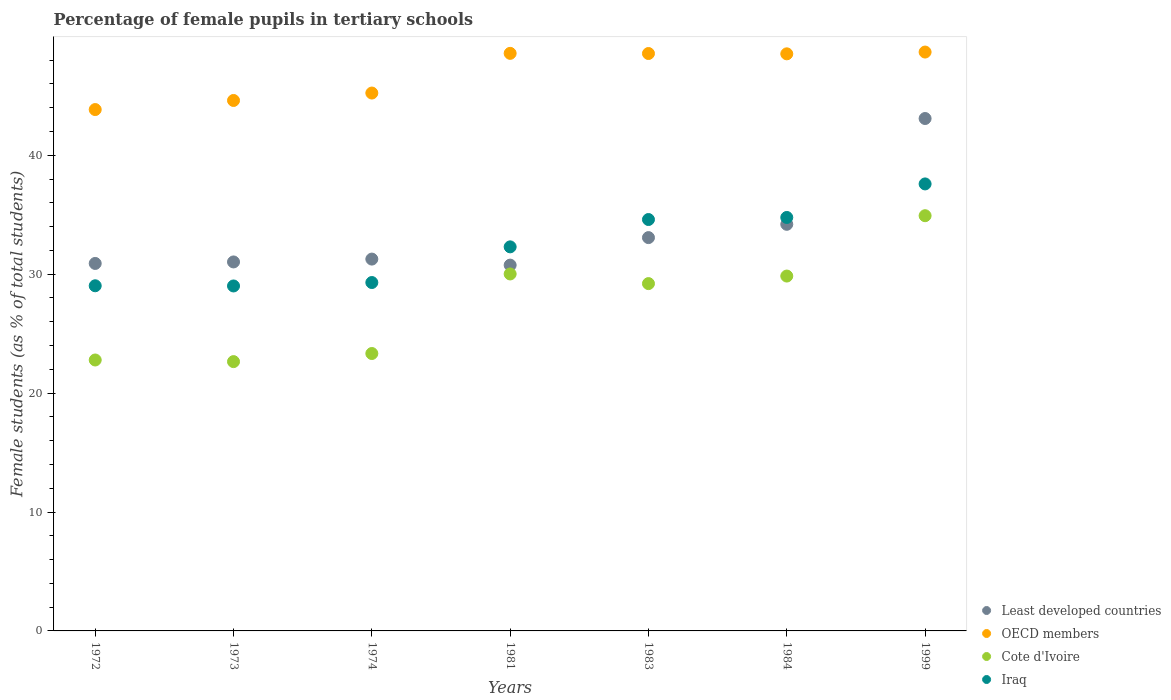How many different coloured dotlines are there?
Your response must be concise. 4. What is the percentage of female pupils in tertiary schools in Cote d'Ivoire in 1999?
Make the answer very short. 34.92. Across all years, what is the maximum percentage of female pupils in tertiary schools in Iraq?
Provide a succinct answer. 37.59. Across all years, what is the minimum percentage of female pupils in tertiary schools in Least developed countries?
Make the answer very short. 30.76. What is the total percentage of female pupils in tertiary schools in Least developed countries in the graph?
Your answer should be compact. 234.33. What is the difference between the percentage of female pupils in tertiary schools in OECD members in 1974 and that in 1999?
Ensure brevity in your answer.  -3.45. What is the difference between the percentage of female pupils in tertiary schools in Iraq in 1972 and the percentage of female pupils in tertiary schools in Cote d'Ivoire in 1999?
Make the answer very short. -5.89. What is the average percentage of female pupils in tertiary schools in Least developed countries per year?
Provide a short and direct response. 33.48. In the year 1972, what is the difference between the percentage of female pupils in tertiary schools in Cote d'Ivoire and percentage of female pupils in tertiary schools in OECD members?
Offer a terse response. -21.06. What is the ratio of the percentage of female pupils in tertiary schools in Iraq in 1972 to that in 1999?
Ensure brevity in your answer.  0.77. Is the percentage of female pupils in tertiary schools in Cote d'Ivoire in 1981 less than that in 1984?
Make the answer very short. No. What is the difference between the highest and the second highest percentage of female pupils in tertiary schools in Least developed countries?
Make the answer very short. 8.9. What is the difference between the highest and the lowest percentage of female pupils in tertiary schools in OECD members?
Offer a terse response. 4.84. How many dotlines are there?
Provide a short and direct response. 4. How many years are there in the graph?
Your response must be concise. 7. What is the difference between two consecutive major ticks on the Y-axis?
Offer a terse response. 10. Does the graph contain any zero values?
Give a very brief answer. No. How many legend labels are there?
Your response must be concise. 4. How are the legend labels stacked?
Your answer should be compact. Vertical. What is the title of the graph?
Offer a terse response. Percentage of female pupils in tertiary schools. Does "Haiti" appear as one of the legend labels in the graph?
Your response must be concise. No. What is the label or title of the X-axis?
Provide a short and direct response. Years. What is the label or title of the Y-axis?
Give a very brief answer. Female students (as % of total students). What is the Female students (as % of total students) of Least developed countries in 1972?
Provide a succinct answer. 30.9. What is the Female students (as % of total students) in OECD members in 1972?
Offer a terse response. 43.84. What is the Female students (as % of total students) in Cote d'Ivoire in 1972?
Ensure brevity in your answer.  22.78. What is the Female students (as % of total students) in Iraq in 1972?
Keep it short and to the point. 29.03. What is the Female students (as % of total students) of Least developed countries in 1973?
Your answer should be compact. 31.03. What is the Female students (as % of total students) of OECD members in 1973?
Provide a succinct answer. 44.61. What is the Female students (as % of total students) of Cote d'Ivoire in 1973?
Make the answer very short. 22.65. What is the Female students (as % of total students) in Iraq in 1973?
Offer a terse response. 29.01. What is the Female students (as % of total students) of Least developed countries in 1974?
Make the answer very short. 31.27. What is the Female students (as % of total students) in OECD members in 1974?
Provide a short and direct response. 45.23. What is the Female students (as % of total students) in Cote d'Ivoire in 1974?
Offer a terse response. 23.33. What is the Female students (as % of total students) in Iraq in 1974?
Your answer should be very brief. 29.3. What is the Female students (as % of total students) of Least developed countries in 1981?
Provide a succinct answer. 30.76. What is the Female students (as % of total students) of OECD members in 1981?
Give a very brief answer. 48.57. What is the Female students (as % of total students) of Cote d'Ivoire in 1981?
Provide a succinct answer. 30.02. What is the Female students (as % of total students) of Iraq in 1981?
Offer a terse response. 32.3. What is the Female students (as % of total students) in Least developed countries in 1983?
Your answer should be very brief. 33.08. What is the Female students (as % of total students) of OECD members in 1983?
Keep it short and to the point. 48.56. What is the Female students (as % of total students) of Cote d'Ivoire in 1983?
Keep it short and to the point. 29.21. What is the Female students (as % of total students) in Iraq in 1983?
Your response must be concise. 34.6. What is the Female students (as % of total students) of Least developed countries in 1984?
Offer a very short reply. 34.19. What is the Female students (as % of total students) in OECD members in 1984?
Offer a terse response. 48.53. What is the Female students (as % of total students) of Cote d'Ivoire in 1984?
Ensure brevity in your answer.  29.84. What is the Female students (as % of total students) in Iraq in 1984?
Your response must be concise. 34.77. What is the Female students (as % of total students) in Least developed countries in 1999?
Keep it short and to the point. 43.09. What is the Female students (as % of total students) in OECD members in 1999?
Your answer should be compact. 48.68. What is the Female students (as % of total students) of Cote d'Ivoire in 1999?
Your answer should be compact. 34.92. What is the Female students (as % of total students) in Iraq in 1999?
Provide a succinct answer. 37.59. Across all years, what is the maximum Female students (as % of total students) of Least developed countries?
Your answer should be compact. 43.09. Across all years, what is the maximum Female students (as % of total students) in OECD members?
Your answer should be very brief. 48.68. Across all years, what is the maximum Female students (as % of total students) of Cote d'Ivoire?
Offer a terse response. 34.92. Across all years, what is the maximum Female students (as % of total students) of Iraq?
Give a very brief answer. 37.59. Across all years, what is the minimum Female students (as % of total students) in Least developed countries?
Make the answer very short. 30.76. Across all years, what is the minimum Female students (as % of total students) of OECD members?
Make the answer very short. 43.84. Across all years, what is the minimum Female students (as % of total students) of Cote d'Ivoire?
Keep it short and to the point. 22.65. Across all years, what is the minimum Female students (as % of total students) in Iraq?
Provide a succinct answer. 29.01. What is the total Female students (as % of total students) of Least developed countries in the graph?
Offer a very short reply. 234.33. What is the total Female students (as % of total students) in OECD members in the graph?
Your answer should be very brief. 328.02. What is the total Female students (as % of total students) of Cote d'Ivoire in the graph?
Offer a very short reply. 192.75. What is the total Female students (as % of total students) of Iraq in the graph?
Your answer should be very brief. 226.59. What is the difference between the Female students (as % of total students) in Least developed countries in 1972 and that in 1973?
Your answer should be very brief. -0.13. What is the difference between the Female students (as % of total students) of OECD members in 1972 and that in 1973?
Provide a short and direct response. -0.76. What is the difference between the Female students (as % of total students) of Cote d'Ivoire in 1972 and that in 1973?
Keep it short and to the point. 0.14. What is the difference between the Female students (as % of total students) in Iraq in 1972 and that in 1973?
Your answer should be very brief. 0.02. What is the difference between the Female students (as % of total students) of Least developed countries in 1972 and that in 1974?
Make the answer very short. -0.37. What is the difference between the Female students (as % of total students) of OECD members in 1972 and that in 1974?
Your response must be concise. -1.39. What is the difference between the Female students (as % of total students) in Cote d'Ivoire in 1972 and that in 1974?
Give a very brief answer. -0.54. What is the difference between the Female students (as % of total students) in Iraq in 1972 and that in 1974?
Offer a very short reply. -0.27. What is the difference between the Female students (as % of total students) in Least developed countries in 1972 and that in 1981?
Provide a succinct answer. 0.14. What is the difference between the Female students (as % of total students) of OECD members in 1972 and that in 1981?
Keep it short and to the point. -4.73. What is the difference between the Female students (as % of total students) in Cote d'Ivoire in 1972 and that in 1981?
Provide a short and direct response. -7.24. What is the difference between the Female students (as % of total students) of Iraq in 1972 and that in 1981?
Provide a short and direct response. -3.27. What is the difference between the Female students (as % of total students) in Least developed countries in 1972 and that in 1983?
Your response must be concise. -2.17. What is the difference between the Female students (as % of total students) of OECD members in 1972 and that in 1983?
Offer a very short reply. -4.71. What is the difference between the Female students (as % of total students) of Cote d'Ivoire in 1972 and that in 1983?
Your answer should be compact. -6.42. What is the difference between the Female students (as % of total students) of Iraq in 1972 and that in 1983?
Offer a terse response. -5.57. What is the difference between the Female students (as % of total students) of Least developed countries in 1972 and that in 1984?
Provide a succinct answer. -3.29. What is the difference between the Female students (as % of total students) of OECD members in 1972 and that in 1984?
Give a very brief answer. -4.69. What is the difference between the Female students (as % of total students) in Cote d'Ivoire in 1972 and that in 1984?
Provide a succinct answer. -7.06. What is the difference between the Female students (as % of total students) of Iraq in 1972 and that in 1984?
Provide a succinct answer. -5.74. What is the difference between the Female students (as % of total students) in Least developed countries in 1972 and that in 1999?
Your answer should be very brief. -12.19. What is the difference between the Female students (as % of total students) in OECD members in 1972 and that in 1999?
Make the answer very short. -4.84. What is the difference between the Female students (as % of total students) in Cote d'Ivoire in 1972 and that in 1999?
Offer a very short reply. -12.13. What is the difference between the Female students (as % of total students) in Iraq in 1972 and that in 1999?
Your response must be concise. -8.56. What is the difference between the Female students (as % of total students) of Least developed countries in 1973 and that in 1974?
Your answer should be compact. -0.24. What is the difference between the Female students (as % of total students) of OECD members in 1973 and that in 1974?
Make the answer very short. -0.62. What is the difference between the Female students (as % of total students) in Cote d'Ivoire in 1973 and that in 1974?
Make the answer very short. -0.68. What is the difference between the Female students (as % of total students) in Iraq in 1973 and that in 1974?
Make the answer very short. -0.29. What is the difference between the Female students (as % of total students) of Least developed countries in 1973 and that in 1981?
Ensure brevity in your answer.  0.27. What is the difference between the Female students (as % of total students) of OECD members in 1973 and that in 1981?
Ensure brevity in your answer.  -3.96. What is the difference between the Female students (as % of total students) of Cote d'Ivoire in 1973 and that in 1981?
Your answer should be compact. -7.37. What is the difference between the Female students (as % of total students) in Iraq in 1973 and that in 1981?
Provide a short and direct response. -3.29. What is the difference between the Female students (as % of total students) in Least developed countries in 1973 and that in 1983?
Provide a short and direct response. -2.05. What is the difference between the Female students (as % of total students) of OECD members in 1973 and that in 1983?
Ensure brevity in your answer.  -3.95. What is the difference between the Female students (as % of total students) of Cote d'Ivoire in 1973 and that in 1983?
Make the answer very short. -6.56. What is the difference between the Female students (as % of total students) in Iraq in 1973 and that in 1983?
Provide a succinct answer. -5.59. What is the difference between the Female students (as % of total students) in Least developed countries in 1973 and that in 1984?
Offer a very short reply. -3.16. What is the difference between the Female students (as % of total students) in OECD members in 1973 and that in 1984?
Make the answer very short. -3.92. What is the difference between the Female students (as % of total students) in Cote d'Ivoire in 1973 and that in 1984?
Your answer should be compact. -7.2. What is the difference between the Female students (as % of total students) in Iraq in 1973 and that in 1984?
Provide a short and direct response. -5.76. What is the difference between the Female students (as % of total students) in Least developed countries in 1973 and that in 1999?
Make the answer very short. -12.06. What is the difference between the Female students (as % of total students) of OECD members in 1973 and that in 1999?
Keep it short and to the point. -4.07. What is the difference between the Female students (as % of total students) of Cote d'Ivoire in 1973 and that in 1999?
Provide a succinct answer. -12.27. What is the difference between the Female students (as % of total students) of Iraq in 1973 and that in 1999?
Offer a terse response. -8.58. What is the difference between the Female students (as % of total students) of Least developed countries in 1974 and that in 1981?
Your answer should be very brief. 0.51. What is the difference between the Female students (as % of total students) in OECD members in 1974 and that in 1981?
Offer a terse response. -3.34. What is the difference between the Female students (as % of total students) of Cote d'Ivoire in 1974 and that in 1981?
Ensure brevity in your answer.  -6.69. What is the difference between the Female students (as % of total students) of Iraq in 1974 and that in 1981?
Offer a terse response. -3. What is the difference between the Female students (as % of total students) in Least developed countries in 1974 and that in 1983?
Provide a succinct answer. -1.81. What is the difference between the Female students (as % of total students) in OECD members in 1974 and that in 1983?
Provide a short and direct response. -3.32. What is the difference between the Female students (as % of total students) of Cote d'Ivoire in 1974 and that in 1983?
Offer a very short reply. -5.88. What is the difference between the Female students (as % of total students) of Iraq in 1974 and that in 1983?
Provide a succinct answer. -5.3. What is the difference between the Female students (as % of total students) of Least developed countries in 1974 and that in 1984?
Your answer should be compact. -2.93. What is the difference between the Female students (as % of total students) in OECD members in 1974 and that in 1984?
Provide a short and direct response. -3.3. What is the difference between the Female students (as % of total students) of Cote d'Ivoire in 1974 and that in 1984?
Offer a terse response. -6.51. What is the difference between the Female students (as % of total students) in Iraq in 1974 and that in 1984?
Offer a terse response. -5.47. What is the difference between the Female students (as % of total students) in Least developed countries in 1974 and that in 1999?
Keep it short and to the point. -11.82. What is the difference between the Female students (as % of total students) of OECD members in 1974 and that in 1999?
Make the answer very short. -3.45. What is the difference between the Female students (as % of total students) of Cote d'Ivoire in 1974 and that in 1999?
Provide a succinct answer. -11.59. What is the difference between the Female students (as % of total students) in Iraq in 1974 and that in 1999?
Provide a succinct answer. -8.29. What is the difference between the Female students (as % of total students) in Least developed countries in 1981 and that in 1983?
Provide a short and direct response. -2.31. What is the difference between the Female students (as % of total students) in OECD members in 1981 and that in 1983?
Your response must be concise. 0.01. What is the difference between the Female students (as % of total students) in Cote d'Ivoire in 1981 and that in 1983?
Your answer should be compact. 0.81. What is the difference between the Female students (as % of total students) of Iraq in 1981 and that in 1983?
Offer a very short reply. -2.3. What is the difference between the Female students (as % of total students) in Least developed countries in 1981 and that in 1984?
Keep it short and to the point. -3.43. What is the difference between the Female students (as % of total students) of OECD members in 1981 and that in 1984?
Your answer should be compact. 0.04. What is the difference between the Female students (as % of total students) in Cote d'Ivoire in 1981 and that in 1984?
Your response must be concise. 0.18. What is the difference between the Female students (as % of total students) in Iraq in 1981 and that in 1984?
Offer a terse response. -2.47. What is the difference between the Female students (as % of total students) in Least developed countries in 1981 and that in 1999?
Your answer should be compact. -12.33. What is the difference between the Female students (as % of total students) in OECD members in 1981 and that in 1999?
Provide a succinct answer. -0.11. What is the difference between the Female students (as % of total students) in Cote d'Ivoire in 1981 and that in 1999?
Offer a terse response. -4.9. What is the difference between the Female students (as % of total students) in Iraq in 1981 and that in 1999?
Your answer should be compact. -5.29. What is the difference between the Female students (as % of total students) of Least developed countries in 1983 and that in 1984?
Your response must be concise. -1.12. What is the difference between the Female students (as % of total students) of OECD members in 1983 and that in 1984?
Your answer should be compact. 0.03. What is the difference between the Female students (as % of total students) of Cote d'Ivoire in 1983 and that in 1984?
Make the answer very short. -0.63. What is the difference between the Female students (as % of total students) of Iraq in 1983 and that in 1984?
Provide a succinct answer. -0.17. What is the difference between the Female students (as % of total students) in Least developed countries in 1983 and that in 1999?
Offer a terse response. -10.02. What is the difference between the Female students (as % of total students) of OECD members in 1983 and that in 1999?
Provide a short and direct response. -0.12. What is the difference between the Female students (as % of total students) of Cote d'Ivoire in 1983 and that in 1999?
Provide a short and direct response. -5.71. What is the difference between the Female students (as % of total students) in Iraq in 1983 and that in 1999?
Provide a succinct answer. -2.99. What is the difference between the Female students (as % of total students) in Least developed countries in 1984 and that in 1999?
Offer a terse response. -8.9. What is the difference between the Female students (as % of total students) of OECD members in 1984 and that in 1999?
Offer a very short reply. -0.15. What is the difference between the Female students (as % of total students) in Cote d'Ivoire in 1984 and that in 1999?
Your response must be concise. -5.08. What is the difference between the Female students (as % of total students) in Iraq in 1984 and that in 1999?
Your answer should be compact. -2.82. What is the difference between the Female students (as % of total students) of Least developed countries in 1972 and the Female students (as % of total students) of OECD members in 1973?
Offer a very short reply. -13.71. What is the difference between the Female students (as % of total students) in Least developed countries in 1972 and the Female students (as % of total students) in Cote d'Ivoire in 1973?
Your answer should be compact. 8.26. What is the difference between the Female students (as % of total students) of Least developed countries in 1972 and the Female students (as % of total students) of Iraq in 1973?
Offer a very short reply. 1.89. What is the difference between the Female students (as % of total students) of OECD members in 1972 and the Female students (as % of total students) of Cote d'Ivoire in 1973?
Keep it short and to the point. 21.2. What is the difference between the Female students (as % of total students) in OECD members in 1972 and the Female students (as % of total students) in Iraq in 1973?
Make the answer very short. 14.83. What is the difference between the Female students (as % of total students) of Cote d'Ivoire in 1972 and the Female students (as % of total students) of Iraq in 1973?
Make the answer very short. -6.23. What is the difference between the Female students (as % of total students) of Least developed countries in 1972 and the Female students (as % of total students) of OECD members in 1974?
Offer a very short reply. -14.33. What is the difference between the Female students (as % of total students) of Least developed countries in 1972 and the Female students (as % of total students) of Cote d'Ivoire in 1974?
Give a very brief answer. 7.57. What is the difference between the Female students (as % of total students) of Least developed countries in 1972 and the Female students (as % of total students) of Iraq in 1974?
Provide a short and direct response. 1.6. What is the difference between the Female students (as % of total students) in OECD members in 1972 and the Female students (as % of total students) in Cote d'Ivoire in 1974?
Your answer should be compact. 20.52. What is the difference between the Female students (as % of total students) in OECD members in 1972 and the Female students (as % of total students) in Iraq in 1974?
Offer a terse response. 14.55. What is the difference between the Female students (as % of total students) of Cote d'Ivoire in 1972 and the Female students (as % of total students) of Iraq in 1974?
Your answer should be very brief. -6.51. What is the difference between the Female students (as % of total students) in Least developed countries in 1972 and the Female students (as % of total students) in OECD members in 1981?
Your response must be concise. -17.67. What is the difference between the Female students (as % of total students) in Least developed countries in 1972 and the Female students (as % of total students) in Cote d'Ivoire in 1981?
Give a very brief answer. 0.88. What is the difference between the Female students (as % of total students) in Least developed countries in 1972 and the Female students (as % of total students) in Iraq in 1981?
Offer a very short reply. -1.4. What is the difference between the Female students (as % of total students) of OECD members in 1972 and the Female students (as % of total students) of Cote d'Ivoire in 1981?
Ensure brevity in your answer.  13.83. What is the difference between the Female students (as % of total students) of OECD members in 1972 and the Female students (as % of total students) of Iraq in 1981?
Ensure brevity in your answer.  11.55. What is the difference between the Female students (as % of total students) in Cote d'Ivoire in 1972 and the Female students (as % of total students) in Iraq in 1981?
Your response must be concise. -9.51. What is the difference between the Female students (as % of total students) of Least developed countries in 1972 and the Female students (as % of total students) of OECD members in 1983?
Provide a succinct answer. -17.65. What is the difference between the Female students (as % of total students) in Least developed countries in 1972 and the Female students (as % of total students) in Cote d'Ivoire in 1983?
Offer a very short reply. 1.69. What is the difference between the Female students (as % of total students) of Least developed countries in 1972 and the Female students (as % of total students) of Iraq in 1983?
Your answer should be very brief. -3.69. What is the difference between the Female students (as % of total students) in OECD members in 1972 and the Female students (as % of total students) in Cote d'Ivoire in 1983?
Your answer should be compact. 14.64. What is the difference between the Female students (as % of total students) in OECD members in 1972 and the Female students (as % of total students) in Iraq in 1983?
Your response must be concise. 9.25. What is the difference between the Female students (as % of total students) of Cote d'Ivoire in 1972 and the Female students (as % of total students) of Iraq in 1983?
Give a very brief answer. -11.81. What is the difference between the Female students (as % of total students) in Least developed countries in 1972 and the Female students (as % of total students) in OECD members in 1984?
Give a very brief answer. -17.63. What is the difference between the Female students (as % of total students) in Least developed countries in 1972 and the Female students (as % of total students) in Cote d'Ivoire in 1984?
Keep it short and to the point. 1.06. What is the difference between the Female students (as % of total students) in Least developed countries in 1972 and the Female students (as % of total students) in Iraq in 1984?
Offer a terse response. -3.87. What is the difference between the Female students (as % of total students) in OECD members in 1972 and the Female students (as % of total students) in Cote d'Ivoire in 1984?
Make the answer very short. 14. What is the difference between the Female students (as % of total students) of OECD members in 1972 and the Female students (as % of total students) of Iraq in 1984?
Offer a very short reply. 9.07. What is the difference between the Female students (as % of total students) in Cote d'Ivoire in 1972 and the Female students (as % of total students) in Iraq in 1984?
Provide a succinct answer. -11.99. What is the difference between the Female students (as % of total students) of Least developed countries in 1972 and the Female students (as % of total students) of OECD members in 1999?
Ensure brevity in your answer.  -17.78. What is the difference between the Female students (as % of total students) in Least developed countries in 1972 and the Female students (as % of total students) in Cote d'Ivoire in 1999?
Offer a very short reply. -4.02. What is the difference between the Female students (as % of total students) of Least developed countries in 1972 and the Female students (as % of total students) of Iraq in 1999?
Offer a terse response. -6.69. What is the difference between the Female students (as % of total students) in OECD members in 1972 and the Female students (as % of total students) in Cote d'Ivoire in 1999?
Provide a succinct answer. 8.93. What is the difference between the Female students (as % of total students) in OECD members in 1972 and the Female students (as % of total students) in Iraq in 1999?
Offer a very short reply. 6.25. What is the difference between the Female students (as % of total students) in Cote d'Ivoire in 1972 and the Female students (as % of total students) in Iraq in 1999?
Keep it short and to the point. -14.81. What is the difference between the Female students (as % of total students) of Least developed countries in 1973 and the Female students (as % of total students) of OECD members in 1974?
Provide a short and direct response. -14.2. What is the difference between the Female students (as % of total students) in Least developed countries in 1973 and the Female students (as % of total students) in Cote d'Ivoire in 1974?
Your answer should be compact. 7.7. What is the difference between the Female students (as % of total students) of Least developed countries in 1973 and the Female students (as % of total students) of Iraq in 1974?
Your response must be concise. 1.73. What is the difference between the Female students (as % of total students) of OECD members in 1973 and the Female students (as % of total students) of Cote d'Ivoire in 1974?
Your response must be concise. 21.28. What is the difference between the Female students (as % of total students) in OECD members in 1973 and the Female students (as % of total students) in Iraq in 1974?
Your response must be concise. 15.31. What is the difference between the Female students (as % of total students) of Cote d'Ivoire in 1973 and the Female students (as % of total students) of Iraq in 1974?
Provide a short and direct response. -6.65. What is the difference between the Female students (as % of total students) of Least developed countries in 1973 and the Female students (as % of total students) of OECD members in 1981?
Ensure brevity in your answer.  -17.54. What is the difference between the Female students (as % of total students) of Least developed countries in 1973 and the Female students (as % of total students) of Cote d'Ivoire in 1981?
Offer a terse response. 1.01. What is the difference between the Female students (as % of total students) of Least developed countries in 1973 and the Female students (as % of total students) of Iraq in 1981?
Your answer should be compact. -1.27. What is the difference between the Female students (as % of total students) of OECD members in 1973 and the Female students (as % of total students) of Cote d'Ivoire in 1981?
Ensure brevity in your answer.  14.59. What is the difference between the Female students (as % of total students) in OECD members in 1973 and the Female students (as % of total students) in Iraq in 1981?
Provide a short and direct response. 12.31. What is the difference between the Female students (as % of total students) in Cote d'Ivoire in 1973 and the Female students (as % of total students) in Iraq in 1981?
Make the answer very short. -9.65. What is the difference between the Female students (as % of total students) of Least developed countries in 1973 and the Female students (as % of total students) of OECD members in 1983?
Provide a succinct answer. -17.53. What is the difference between the Female students (as % of total students) of Least developed countries in 1973 and the Female students (as % of total students) of Cote d'Ivoire in 1983?
Keep it short and to the point. 1.82. What is the difference between the Female students (as % of total students) in Least developed countries in 1973 and the Female students (as % of total students) in Iraq in 1983?
Give a very brief answer. -3.57. What is the difference between the Female students (as % of total students) in OECD members in 1973 and the Female students (as % of total students) in Cote d'Ivoire in 1983?
Provide a short and direct response. 15.4. What is the difference between the Female students (as % of total students) in OECD members in 1973 and the Female students (as % of total students) in Iraq in 1983?
Your answer should be very brief. 10.01. What is the difference between the Female students (as % of total students) in Cote d'Ivoire in 1973 and the Female students (as % of total students) in Iraq in 1983?
Make the answer very short. -11.95. What is the difference between the Female students (as % of total students) in Least developed countries in 1973 and the Female students (as % of total students) in OECD members in 1984?
Provide a succinct answer. -17.5. What is the difference between the Female students (as % of total students) of Least developed countries in 1973 and the Female students (as % of total students) of Cote d'Ivoire in 1984?
Provide a succinct answer. 1.19. What is the difference between the Female students (as % of total students) of Least developed countries in 1973 and the Female students (as % of total students) of Iraq in 1984?
Provide a short and direct response. -3.74. What is the difference between the Female students (as % of total students) in OECD members in 1973 and the Female students (as % of total students) in Cote d'Ivoire in 1984?
Your answer should be compact. 14.77. What is the difference between the Female students (as % of total students) of OECD members in 1973 and the Female students (as % of total students) of Iraq in 1984?
Keep it short and to the point. 9.84. What is the difference between the Female students (as % of total students) of Cote d'Ivoire in 1973 and the Female students (as % of total students) of Iraq in 1984?
Give a very brief answer. -12.12. What is the difference between the Female students (as % of total students) of Least developed countries in 1973 and the Female students (as % of total students) of OECD members in 1999?
Your response must be concise. -17.65. What is the difference between the Female students (as % of total students) of Least developed countries in 1973 and the Female students (as % of total students) of Cote d'Ivoire in 1999?
Ensure brevity in your answer.  -3.89. What is the difference between the Female students (as % of total students) of Least developed countries in 1973 and the Female students (as % of total students) of Iraq in 1999?
Your answer should be compact. -6.56. What is the difference between the Female students (as % of total students) in OECD members in 1973 and the Female students (as % of total students) in Cote d'Ivoire in 1999?
Ensure brevity in your answer.  9.69. What is the difference between the Female students (as % of total students) in OECD members in 1973 and the Female students (as % of total students) in Iraq in 1999?
Provide a short and direct response. 7.02. What is the difference between the Female students (as % of total students) in Cote d'Ivoire in 1973 and the Female students (as % of total students) in Iraq in 1999?
Provide a succinct answer. -14.94. What is the difference between the Female students (as % of total students) of Least developed countries in 1974 and the Female students (as % of total students) of OECD members in 1981?
Offer a terse response. -17.3. What is the difference between the Female students (as % of total students) in Least developed countries in 1974 and the Female students (as % of total students) in Cote d'Ivoire in 1981?
Ensure brevity in your answer.  1.25. What is the difference between the Female students (as % of total students) of Least developed countries in 1974 and the Female students (as % of total students) of Iraq in 1981?
Offer a terse response. -1.03. What is the difference between the Female students (as % of total students) of OECD members in 1974 and the Female students (as % of total students) of Cote d'Ivoire in 1981?
Ensure brevity in your answer.  15.21. What is the difference between the Female students (as % of total students) in OECD members in 1974 and the Female students (as % of total students) in Iraq in 1981?
Your answer should be compact. 12.94. What is the difference between the Female students (as % of total students) of Cote d'Ivoire in 1974 and the Female students (as % of total students) of Iraq in 1981?
Keep it short and to the point. -8.97. What is the difference between the Female students (as % of total students) in Least developed countries in 1974 and the Female students (as % of total students) in OECD members in 1983?
Offer a very short reply. -17.29. What is the difference between the Female students (as % of total students) in Least developed countries in 1974 and the Female students (as % of total students) in Cote d'Ivoire in 1983?
Offer a very short reply. 2.06. What is the difference between the Female students (as % of total students) in Least developed countries in 1974 and the Female students (as % of total students) in Iraq in 1983?
Give a very brief answer. -3.33. What is the difference between the Female students (as % of total students) of OECD members in 1974 and the Female students (as % of total students) of Cote d'Ivoire in 1983?
Provide a short and direct response. 16.03. What is the difference between the Female students (as % of total students) in OECD members in 1974 and the Female students (as % of total students) in Iraq in 1983?
Provide a succinct answer. 10.64. What is the difference between the Female students (as % of total students) of Cote d'Ivoire in 1974 and the Female students (as % of total students) of Iraq in 1983?
Offer a very short reply. -11.27. What is the difference between the Female students (as % of total students) of Least developed countries in 1974 and the Female students (as % of total students) of OECD members in 1984?
Provide a succinct answer. -17.26. What is the difference between the Female students (as % of total students) in Least developed countries in 1974 and the Female students (as % of total students) in Cote d'Ivoire in 1984?
Make the answer very short. 1.43. What is the difference between the Female students (as % of total students) of Least developed countries in 1974 and the Female students (as % of total students) of Iraq in 1984?
Your answer should be very brief. -3.5. What is the difference between the Female students (as % of total students) in OECD members in 1974 and the Female students (as % of total students) in Cote d'Ivoire in 1984?
Your response must be concise. 15.39. What is the difference between the Female students (as % of total students) in OECD members in 1974 and the Female students (as % of total students) in Iraq in 1984?
Provide a succinct answer. 10.46. What is the difference between the Female students (as % of total students) in Cote d'Ivoire in 1974 and the Female students (as % of total students) in Iraq in 1984?
Make the answer very short. -11.44. What is the difference between the Female students (as % of total students) of Least developed countries in 1974 and the Female students (as % of total students) of OECD members in 1999?
Provide a succinct answer. -17.41. What is the difference between the Female students (as % of total students) of Least developed countries in 1974 and the Female students (as % of total students) of Cote d'Ivoire in 1999?
Offer a terse response. -3.65. What is the difference between the Female students (as % of total students) of Least developed countries in 1974 and the Female students (as % of total students) of Iraq in 1999?
Make the answer very short. -6.32. What is the difference between the Female students (as % of total students) of OECD members in 1974 and the Female students (as % of total students) of Cote d'Ivoire in 1999?
Make the answer very short. 10.32. What is the difference between the Female students (as % of total students) of OECD members in 1974 and the Female students (as % of total students) of Iraq in 1999?
Offer a very short reply. 7.64. What is the difference between the Female students (as % of total students) in Cote d'Ivoire in 1974 and the Female students (as % of total students) in Iraq in 1999?
Offer a very short reply. -14.26. What is the difference between the Female students (as % of total students) in Least developed countries in 1981 and the Female students (as % of total students) in OECD members in 1983?
Your answer should be compact. -17.8. What is the difference between the Female students (as % of total students) of Least developed countries in 1981 and the Female students (as % of total students) of Cote d'Ivoire in 1983?
Offer a terse response. 1.55. What is the difference between the Female students (as % of total students) in Least developed countries in 1981 and the Female students (as % of total students) in Iraq in 1983?
Make the answer very short. -3.83. What is the difference between the Female students (as % of total students) of OECD members in 1981 and the Female students (as % of total students) of Cote d'Ivoire in 1983?
Provide a succinct answer. 19.36. What is the difference between the Female students (as % of total students) in OECD members in 1981 and the Female students (as % of total students) in Iraq in 1983?
Offer a very short reply. 13.97. What is the difference between the Female students (as % of total students) of Cote d'Ivoire in 1981 and the Female students (as % of total students) of Iraq in 1983?
Offer a terse response. -4.58. What is the difference between the Female students (as % of total students) in Least developed countries in 1981 and the Female students (as % of total students) in OECD members in 1984?
Give a very brief answer. -17.77. What is the difference between the Female students (as % of total students) in Least developed countries in 1981 and the Female students (as % of total students) in Cote d'Ivoire in 1984?
Provide a succinct answer. 0.92. What is the difference between the Female students (as % of total students) of Least developed countries in 1981 and the Female students (as % of total students) of Iraq in 1984?
Offer a terse response. -4.01. What is the difference between the Female students (as % of total students) in OECD members in 1981 and the Female students (as % of total students) in Cote d'Ivoire in 1984?
Your answer should be compact. 18.73. What is the difference between the Female students (as % of total students) in OECD members in 1981 and the Female students (as % of total students) in Iraq in 1984?
Offer a terse response. 13.8. What is the difference between the Female students (as % of total students) in Cote d'Ivoire in 1981 and the Female students (as % of total students) in Iraq in 1984?
Provide a succinct answer. -4.75. What is the difference between the Female students (as % of total students) of Least developed countries in 1981 and the Female students (as % of total students) of OECD members in 1999?
Make the answer very short. -17.92. What is the difference between the Female students (as % of total students) in Least developed countries in 1981 and the Female students (as % of total students) in Cote d'Ivoire in 1999?
Your answer should be very brief. -4.16. What is the difference between the Female students (as % of total students) in Least developed countries in 1981 and the Female students (as % of total students) in Iraq in 1999?
Ensure brevity in your answer.  -6.83. What is the difference between the Female students (as % of total students) in OECD members in 1981 and the Female students (as % of total students) in Cote d'Ivoire in 1999?
Ensure brevity in your answer.  13.65. What is the difference between the Female students (as % of total students) of OECD members in 1981 and the Female students (as % of total students) of Iraq in 1999?
Provide a short and direct response. 10.98. What is the difference between the Female students (as % of total students) in Cote d'Ivoire in 1981 and the Female students (as % of total students) in Iraq in 1999?
Your response must be concise. -7.57. What is the difference between the Female students (as % of total students) in Least developed countries in 1983 and the Female students (as % of total students) in OECD members in 1984?
Your response must be concise. -15.45. What is the difference between the Female students (as % of total students) in Least developed countries in 1983 and the Female students (as % of total students) in Cote d'Ivoire in 1984?
Your response must be concise. 3.23. What is the difference between the Female students (as % of total students) of Least developed countries in 1983 and the Female students (as % of total students) of Iraq in 1984?
Provide a short and direct response. -1.69. What is the difference between the Female students (as % of total students) of OECD members in 1983 and the Female students (as % of total students) of Cote d'Ivoire in 1984?
Offer a very short reply. 18.71. What is the difference between the Female students (as % of total students) in OECD members in 1983 and the Female students (as % of total students) in Iraq in 1984?
Your response must be concise. 13.79. What is the difference between the Female students (as % of total students) of Cote d'Ivoire in 1983 and the Female students (as % of total students) of Iraq in 1984?
Offer a terse response. -5.56. What is the difference between the Female students (as % of total students) of Least developed countries in 1983 and the Female students (as % of total students) of OECD members in 1999?
Your response must be concise. -15.6. What is the difference between the Female students (as % of total students) of Least developed countries in 1983 and the Female students (as % of total students) of Cote d'Ivoire in 1999?
Your answer should be compact. -1.84. What is the difference between the Female students (as % of total students) of Least developed countries in 1983 and the Female students (as % of total students) of Iraq in 1999?
Provide a succinct answer. -4.51. What is the difference between the Female students (as % of total students) of OECD members in 1983 and the Female students (as % of total students) of Cote d'Ivoire in 1999?
Give a very brief answer. 13.64. What is the difference between the Female students (as % of total students) in OECD members in 1983 and the Female students (as % of total students) in Iraq in 1999?
Make the answer very short. 10.97. What is the difference between the Female students (as % of total students) of Cote d'Ivoire in 1983 and the Female students (as % of total students) of Iraq in 1999?
Offer a terse response. -8.38. What is the difference between the Female students (as % of total students) in Least developed countries in 1984 and the Female students (as % of total students) in OECD members in 1999?
Your answer should be very brief. -14.49. What is the difference between the Female students (as % of total students) of Least developed countries in 1984 and the Female students (as % of total students) of Cote d'Ivoire in 1999?
Ensure brevity in your answer.  -0.72. What is the difference between the Female students (as % of total students) in Least developed countries in 1984 and the Female students (as % of total students) in Iraq in 1999?
Your response must be concise. -3.4. What is the difference between the Female students (as % of total students) of OECD members in 1984 and the Female students (as % of total students) of Cote d'Ivoire in 1999?
Offer a terse response. 13.61. What is the difference between the Female students (as % of total students) in OECD members in 1984 and the Female students (as % of total students) in Iraq in 1999?
Offer a terse response. 10.94. What is the difference between the Female students (as % of total students) in Cote d'Ivoire in 1984 and the Female students (as % of total students) in Iraq in 1999?
Make the answer very short. -7.75. What is the average Female students (as % of total students) in Least developed countries per year?
Give a very brief answer. 33.48. What is the average Female students (as % of total students) of OECD members per year?
Offer a very short reply. 46.86. What is the average Female students (as % of total students) in Cote d'Ivoire per year?
Your answer should be compact. 27.54. What is the average Female students (as % of total students) of Iraq per year?
Offer a very short reply. 32.37. In the year 1972, what is the difference between the Female students (as % of total students) in Least developed countries and Female students (as % of total students) in OECD members?
Provide a succinct answer. -12.94. In the year 1972, what is the difference between the Female students (as % of total students) of Least developed countries and Female students (as % of total students) of Cote d'Ivoire?
Keep it short and to the point. 8.12. In the year 1972, what is the difference between the Female students (as % of total students) of Least developed countries and Female students (as % of total students) of Iraq?
Ensure brevity in your answer.  1.88. In the year 1972, what is the difference between the Female students (as % of total students) in OECD members and Female students (as % of total students) in Cote d'Ivoire?
Keep it short and to the point. 21.06. In the year 1972, what is the difference between the Female students (as % of total students) in OECD members and Female students (as % of total students) in Iraq?
Provide a succinct answer. 14.82. In the year 1972, what is the difference between the Female students (as % of total students) of Cote d'Ivoire and Female students (as % of total students) of Iraq?
Ensure brevity in your answer.  -6.24. In the year 1973, what is the difference between the Female students (as % of total students) of Least developed countries and Female students (as % of total students) of OECD members?
Ensure brevity in your answer.  -13.58. In the year 1973, what is the difference between the Female students (as % of total students) in Least developed countries and Female students (as % of total students) in Cote d'Ivoire?
Ensure brevity in your answer.  8.38. In the year 1973, what is the difference between the Female students (as % of total students) in Least developed countries and Female students (as % of total students) in Iraq?
Provide a short and direct response. 2.02. In the year 1973, what is the difference between the Female students (as % of total students) in OECD members and Female students (as % of total students) in Cote d'Ivoire?
Make the answer very short. 21.96. In the year 1973, what is the difference between the Female students (as % of total students) of OECD members and Female students (as % of total students) of Iraq?
Your answer should be very brief. 15.6. In the year 1973, what is the difference between the Female students (as % of total students) of Cote d'Ivoire and Female students (as % of total students) of Iraq?
Ensure brevity in your answer.  -6.36. In the year 1974, what is the difference between the Female students (as % of total students) of Least developed countries and Female students (as % of total students) of OECD members?
Your answer should be compact. -13.96. In the year 1974, what is the difference between the Female students (as % of total students) of Least developed countries and Female students (as % of total students) of Cote d'Ivoire?
Ensure brevity in your answer.  7.94. In the year 1974, what is the difference between the Female students (as % of total students) of Least developed countries and Female students (as % of total students) of Iraq?
Provide a succinct answer. 1.97. In the year 1974, what is the difference between the Female students (as % of total students) of OECD members and Female students (as % of total students) of Cote d'Ivoire?
Keep it short and to the point. 21.9. In the year 1974, what is the difference between the Female students (as % of total students) of OECD members and Female students (as % of total students) of Iraq?
Keep it short and to the point. 15.94. In the year 1974, what is the difference between the Female students (as % of total students) in Cote d'Ivoire and Female students (as % of total students) in Iraq?
Offer a very short reply. -5.97. In the year 1981, what is the difference between the Female students (as % of total students) of Least developed countries and Female students (as % of total students) of OECD members?
Your answer should be compact. -17.81. In the year 1981, what is the difference between the Female students (as % of total students) of Least developed countries and Female students (as % of total students) of Cote d'Ivoire?
Give a very brief answer. 0.74. In the year 1981, what is the difference between the Female students (as % of total students) in Least developed countries and Female students (as % of total students) in Iraq?
Provide a succinct answer. -1.54. In the year 1981, what is the difference between the Female students (as % of total students) of OECD members and Female students (as % of total students) of Cote d'Ivoire?
Ensure brevity in your answer.  18.55. In the year 1981, what is the difference between the Female students (as % of total students) in OECD members and Female students (as % of total students) in Iraq?
Provide a short and direct response. 16.27. In the year 1981, what is the difference between the Female students (as % of total students) in Cote d'Ivoire and Female students (as % of total students) in Iraq?
Your response must be concise. -2.28. In the year 1983, what is the difference between the Female students (as % of total students) of Least developed countries and Female students (as % of total students) of OECD members?
Your response must be concise. -15.48. In the year 1983, what is the difference between the Female students (as % of total students) in Least developed countries and Female students (as % of total students) in Cote d'Ivoire?
Offer a terse response. 3.87. In the year 1983, what is the difference between the Female students (as % of total students) of Least developed countries and Female students (as % of total students) of Iraq?
Your answer should be very brief. -1.52. In the year 1983, what is the difference between the Female students (as % of total students) of OECD members and Female students (as % of total students) of Cote d'Ivoire?
Your answer should be compact. 19.35. In the year 1983, what is the difference between the Female students (as % of total students) of OECD members and Female students (as % of total students) of Iraq?
Keep it short and to the point. 13.96. In the year 1983, what is the difference between the Female students (as % of total students) in Cote d'Ivoire and Female students (as % of total students) in Iraq?
Provide a short and direct response. -5.39. In the year 1984, what is the difference between the Female students (as % of total students) in Least developed countries and Female students (as % of total students) in OECD members?
Ensure brevity in your answer.  -14.34. In the year 1984, what is the difference between the Female students (as % of total students) in Least developed countries and Female students (as % of total students) in Cote d'Ivoire?
Provide a short and direct response. 4.35. In the year 1984, what is the difference between the Female students (as % of total students) in Least developed countries and Female students (as % of total students) in Iraq?
Provide a short and direct response. -0.58. In the year 1984, what is the difference between the Female students (as % of total students) in OECD members and Female students (as % of total students) in Cote d'Ivoire?
Provide a short and direct response. 18.69. In the year 1984, what is the difference between the Female students (as % of total students) in OECD members and Female students (as % of total students) in Iraq?
Make the answer very short. 13.76. In the year 1984, what is the difference between the Female students (as % of total students) in Cote d'Ivoire and Female students (as % of total students) in Iraq?
Provide a short and direct response. -4.93. In the year 1999, what is the difference between the Female students (as % of total students) of Least developed countries and Female students (as % of total students) of OECD members?
Give a very brief answer. -5.59. In the year 1999, what is the difference between the Female students (as % of total students) in Least developed countries and Female students (as % of total students) in Cote d'Ivoire?
Your answer should be very brief. 8.17. In the year 1999, what is the difference between the Female students (as % of total students) of Least developed countries and Female students (as % of total students) of Iraq?
Make the answer very short. 5.5. In the year 1999, what is the difference between the Female students (as % of total students) in OECD members and Female students (as % of total students) in Cote d'Ivoire?
Provide a short and direct response. 13.76. In the year 1999, what is the difference between the Female students (as % of total students) of OECD members and Female students (as % of total students) of Iraq?
Offer a terse response. 11.09. In the year 1999, what is the difference between the Female students (as % of total students) in Cote d'Ivoire and Female students (as % of total students) in Iraq?
Make the answer very short. -2.67. What is the ratio of the Female students (as % of total students) of Least developed countries in 1972 to that in 1973?
Give a very brief answer. 1. What is the ratio of the Female students (as % of total students) in OECD members in 1972 to that in 1973?
Ensure brevity in your answer.  0.98. What is the ratio of the Female students (as % of total students) of Iraq in 1972 to that in 1973?
Offer a terse response. 1. What is the ratio of the Female students (as % of total students) of Least developed countries in 1972 to that in 1974?
Make the answer very short. 0.99. What is the ratio of the Female students (as % of total students) in OECD members in 1972 to that in 1974?
Offer a terse response. 0.97. What is the ratio of the Female students (as % of total students) of Cote d'Ivoire in 1972 to that in 1974?
Your answer should be very brief. 0.98. What is the ratio of the Female students (as % of total students) of Least developed countries in 1972 to that in 1981?
Make the answer very short. 1. What is the ratio of the Female students (as % of total students) of OECD members in 1972 to that in 1981?
Your answer should be very brief. 0.9. What is the ratio of the Female students (as % of total students) of Cote d'Ivoire in 1972 to that in 1981?
Make the answer very short. 0.76. What is the ratio of the Female students (as % of total students) of Iraq in 1972 to that in 1981?
Offer a terse response. 0.9. What is the ratio of the Female students (as % of total students) in Least developed countries in 1972 to that in 1983?
Your answer should be compact. 0.93. What is the ratio of the Female students (as % of total students) of OECD members in 1972 to that in 1983?
Give a very brief answer. 0.9. What is the ratio of the Female students (as % of total students) in Cote d'Ivoire in 1972 to that in 1983?
Make the answer very short. 0.78. What is the ratio of the Female students (as % of total students) of Iraq in 1972 to that in 1983?
Offer a very short reply. 0.84. What is the ratio of the Female students (as % of total students) in Least developed countries in 1972 to that in 1984?
Make the answer very short. 0.9. What is the ratio of the Female students (as % of total students) of OECD members in 1972 to that in 1984?
Your answer should be very brief. 0.9. What is the ratio of the Female students (as % of total students) in Cote d'Ivoire in 1972 to that in 1984?
Offer a very short reply. 0.76. What is the ratio of the Female students (as % of total students) of Iraq in 1972 to that in 1984?
Offer a terse response. 0.83. What is the ratio of the Female students (as % of total students) in Least developed countries in 1972 to that in 1999?
Your answer should be compact. 0.72. What is the ratio of the Female students (as % of total students) of OECD members in 1972 to that in 1999?
Provide a succinct answer. 0.9. What is the ratio of the Female students (as % of total students) in Cote d'Ivoire in 1972 to that in 1999?
Provide a succinct answer. 0.65. What is the ratio of the Female students (as % of total students) of Iraq in 1972 to that in 1999?
Offer a terse response. 0.77. What is the ratio of the Female students (as % of total students) of OECD members in 1973 to that in 1974?
Give a very brief answer. 0.99. What is the ratio of the Female students (as % of total students) of Cote d'Ivoire in 1973 to that in 1974?
Provide a short and direct response. 0.97. What is the ratio of the Female students (as % of total students) of Iraq in 1973 to that in 1974?
Ensure brevity in your answer.  0.99. What is the ratio of the Female students (as % of total students) in Least developed countries in 1973 to that in 1981?
Your answer should be very brief. 1.01. What is the ratio of the Female students (as % of total students) in OECD members in 1973 to that in 1981?
Your answer should be compact. 0.92. What is the ratio of the Female students (as % of total students) of Cote d'Ivoire in 1973 to that in 1981?
Offer a very short reply. 0.75. What is the ratio of the Female students (as % of total students) in Iraq in 1973 to that in 1981?
Make the answer very short. 0.9. What is the ratio of the Female students (as % of total students) of Least developed countries in 1973 to that in 1983?
Offer a very short reply. 0.94. What is the ratio of the Female students (as % of total students) in OECD members in 1973 to that in 1983?
Make the answer very short. 0.92. What is the ratio of the Female students (as % of total students) in Cote d'Ivoire in 1973 to that in 1983?
Provide a succinct answer. 0.78. What is the ratio of the Female students (as % of total students) in Iraq in 1973 to that in 1983?
Your answer should be compact. 0.84. What is the ratio of the Female students (as % of total students) of Least developed countries in 1973 to that in 1984?
Your response must be concise. 0.91. What is the ratio of the Female students (as % of total students) of OECD members in 1973 to that in 1984?
Ensure brevity in your answer.  0.92. What is the ratio of the Female students (as % of total students) in Cote d'Ivoire in 1973 to that in 1984?
Your answer should be compact. 0.76. What is the ratio of the Female students (as % of total students) of Iraq in 1973 to that in 1984?
Make the answer very short. 0.83. What is the ratio of the Female students (as % of total students) in Least developed countries in 1973 to that in 1999?
Keep it short and to the point. 0.72. What is the ratio of the Female students (as % of total students) in OECD members in 1973 to that in 1999?
Your response must be concise. 0.92. What is the ratio of the Female students (as % of total students) in Cote d'Ivoire in 1973 to that in 1999?
Offer a very short reply. 0.65. What is the ratio of the Female students (as % of total students) in Iraq in 1973 to that in 1999?
Keep it short and to the point. 0.77. What is the ratio of the Female students (as % of total students) of Least developed countries in 1974 to that in 1981?
Your answer should be compact. 1.02. What is the ratio of the Female students (as % of total students) of OECD members in 1974 to that in 1981?
Offer a very short reply. 0.93. What is the ratio of the Female students (as % of total students) in Cote d'Ivoire in 1974 to that in 1981?
Your response must be concise. 0.78. What is the ratio of the Female students (as % of total students) of Iraq in 1974 to that in 1981?
Give a very brief answer. 0.91. What is the ratio of the Female students (as % of total students) in Least developed countries in 1974 to that in 1983?
Your answer should be compact. 0.95. What is the ratio of the Female students (as % of total students) of OECD members in 1974 to that in 1983?
Ensure brevity in your answer.  0.93. What is the ratio of the Female students (as % of total students) of Cote d'Ivoire in 1974 to that in 1983?
Keep it short and to the point. 0.8. What is the ratio of the Female students (as % of total students) in Iraq in 1974 to that in 1983?
Keep it short and to the point. 0.85. What is the ratio of the Female students (as % of total students) of Least developed countries in 1974 to that in 1984?
Your response must be concise. 0.91. What is the ratio of the Female students (as % of total students) of OECD members in 1974 to that in 1984?
Provide a succinct answer. 0.93. What is the ratio of the Female students (as % of total students) of Cote d'Ivoire in 1974 to that in 1984?
Make the answer very short. 0.78. What is the ratio of the Female students (as % of total students) in Iraq in 1974 to that in 1984?
Make the answer very short. 0.84. What is the ratio of the Female students (as % of total students) in Least developed countries in 1974 to that in 1999?
Give a very brief answer. 0.73. What is the ratio of the Female students (as % of total students) in OECD members in 1974 to that in 1999?
Your answer should be compact. 0.93. What is the ratio of the Female students (as % of total students) of Cote d'Ivoire in 1974 to that in 1999?
Your response must be concise. 0.67. What is the ratio of the Female students (as % of total students) in Iraq in 1974 to that in 1999?
Ensure brevity in your answer.  0.78. What is the ratio of the Female students (as % of total students) of Least developed countries in 1981 to that in 1983?
Offer a terse response. 0.93. What is the ratio of the Female students (as % of total students) of OECD members in 1981 to that in 1983?
Provide a succinct answer. 1. What is the ratio of the Female students (as % of total students) in Cote d'Ivoire in 1981 to that in 1983?
Ensure brevity in your answer.  1.03. What is the ratio of the Female students (as % of total students) of Iraq in 1981 to that in 1983?
Your answer should be compact. 0.93. What is the ratio of the Female students (as % of total students) of Least developed countries in 1981 to that in 1984?
Offer a terse response. 0.9. What is the ratio of the Female students (as % of total students) in Cote d'Ivoire in 1981 to that in 1984?
Provide a succinct answer. 1.01. What is the ratio of the Female students (as % of total students) in Iraq in 1981 to that in 1984?
Give a very brief answer. 0.93. What is the ratio of the Female students (as % of total students) in Least developed countries in 1981 to that in 1999?
Your answer should be very brief. 0.71. What is the ratio of the Female students (as % of total students) in OECD members in 1981 to that in 1999?
Ensure brevity in your answer.  1. What is the ratio of the Female students (as % of total students) of Cote d'Ivoire in 1981 to that in 1999?
Your response must be concise. 0.86. What is the ratio of the Female students (as % of total students) of Iraq in 1981 to that in 1999?
Your answer should be compact. 0.86. What is the ratio of the Female students (as % of total students) of Least developed countries in 1983 to that in 1984?
Keep it short and to the point. 0.97. What is the ratio of the Female students (as % of total students) of Cote d'Ivoire in 1983 to that in 1984?
Make the answer very short. 0.98. What is the ratio of the Female students (as % of total students) in Iraq in 1983 to that in 1984?
Make the answer very short. 0.99. What is the ratio of the Female students (as % of total students) in Least developed countries in 1983 to that in 1999?
Make the answer very short. 0.77. What is the ratio of the Female students (as % of total students) in Cote d'Ivoire in 1983 to that in 1999?
Offer a very short reply. 0.84. What is the ratio of the Female students (as % of total students) in Iraq in 1983 to that in 1999?
Provide a short and direct response. 0.92. What is the ratio of the Female students (as % of total students) of Least developed countries in 1984 to that in 1999?
Provide a short and direct response. 0.79. What is the ratio of the Female students (as % of total students) in OECD members in 1984 to that in 1999?
Ensure brevity in your answer.  1. What is the ratio of the Female students (as % of total students) of Cote d'Ivoire in 1984 to that in 1999?
Your answer should be compact. 0.85. What is the ratio of the Female students (as % of total students) of Iraq in 1984 to that in 1999?
Your answer should be very brief. 0.93. What is the difference between the highest and the second highest Female students (as % of total students) in Least developed countries?
Keep it short and to the point. 8.9. What is the difference between the highest and the second highest Female students (as % of total students) of OECD members?
Offer a very short reply. 0.11. What is the difference between the highest and the second highest Female students (as % of total students) in Cote d'Ivoire?
Your answer should be compact. 4.9. What is the difference between the highest and the second highest Female students (as % of total students) of Iraq?
Make the answer very short. 2.82. What is the difference between the highest and the lowest Female students (as % of total students) in Least developed countries?
Ensure brevity in your answer.  12.33. What is the difference between the highest and the lowest Female students (as % of total students) of OECD members?
Make the answer very short. 4.84. What is the difference between the highest and the lowest Female students (as % of total students) in Cote d'Ivoire?
Offer a very short reply. 12.27. What is the difference between the highest and the lowest Female students (as % of total students) in Iraq?
Ensure brevity in your answer.  8.58. 